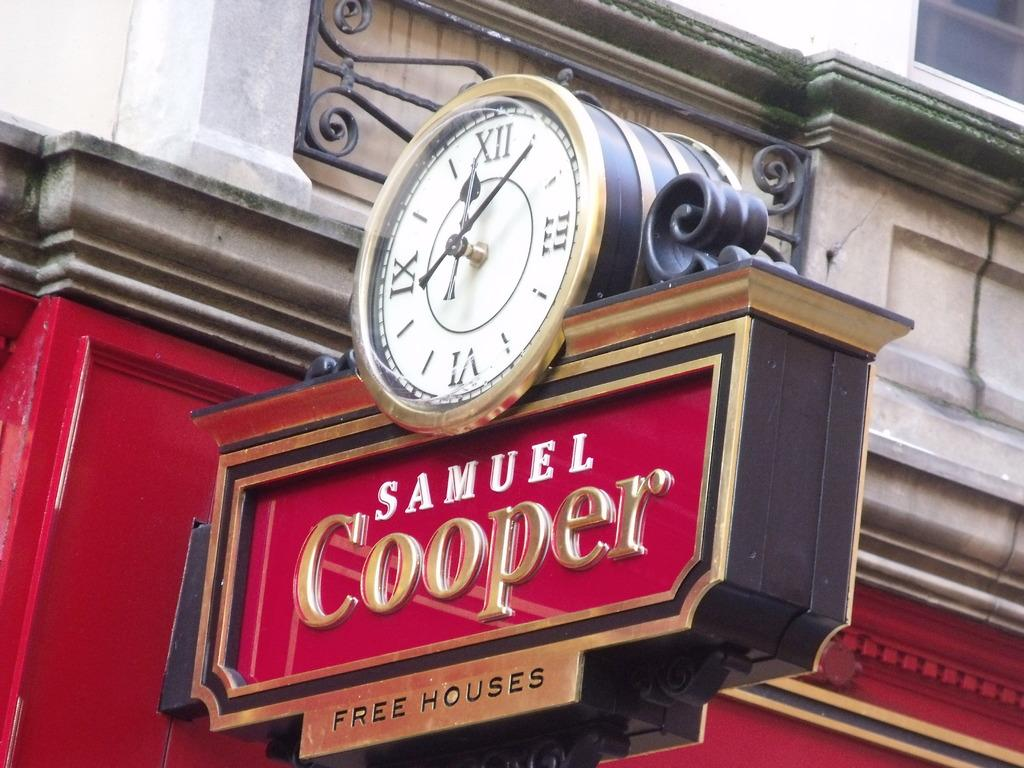<image>
Provide a brief description of the given image. Samuel Cooper free houses sign with a clock on top 